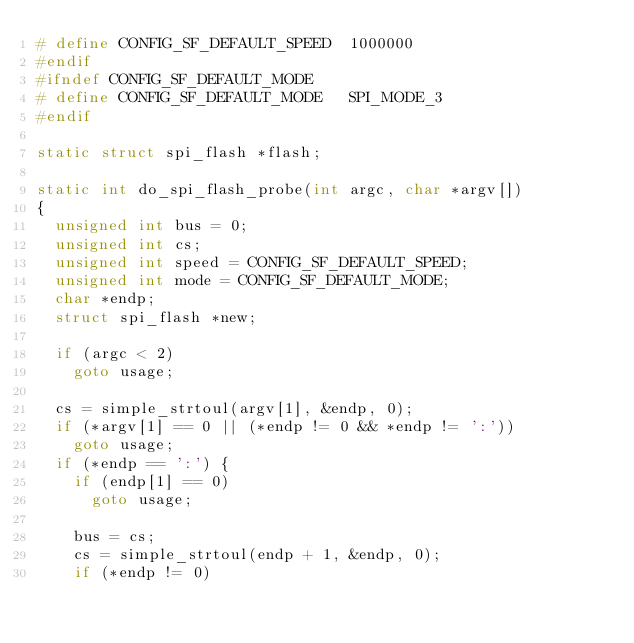Convert code to text. <code><loc_0><loc_0><loc_500><loc_500><_C_># define CONFIG_SF_DEFAULT_SPEED	1000000
#endif
#ifndef CONFIG_SF_DEFAULT_MODE
# define CONFIG_SF_DEFAULT_MODE		SPI_MODE_3
#endif

static struct spi_flash *flash;

static int do_spi_flash_probe(int argc, char *argv[])
{
	unsigned int bus = 0;
	unsigned int cs;
	unsigned int speed = CONFIG_SF_DEFAULT_SPEED;
	unsigned int mode = CONFIG_SF_DEFAULT_MODE;
	char *endp;
	struct spi_flash *new;

	if (argc < 2)
		goto usage;

	cs = simple_strtoul(argv[1], &endp, 0);
	if (*argv[1] == 0 || (*endp != 0 && *endp != ':'))
		goto usage;
	if (*endp == ':') {
		if (endp[1] == 0)
			goto usage;

		bus = cs;
		cs = simple_strtoul(endp + 1, &endp, 0);
		if (*endp != 0)</code> 